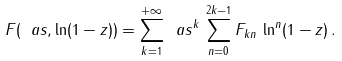Convert formula to latex. <formula><loc_0><loc_0><loc_500><loc_500>F ( \ a s , \ln ( 1 - z ) ) = \sum _ { k = 1 } ^ { + \infty } \ a s ^ { k } \, \sum _ { n = 0 } ^ { 2 k - 1 } F _ { k n } \, \ln ^ { n } ( 1 - z ) \, .</formula> 